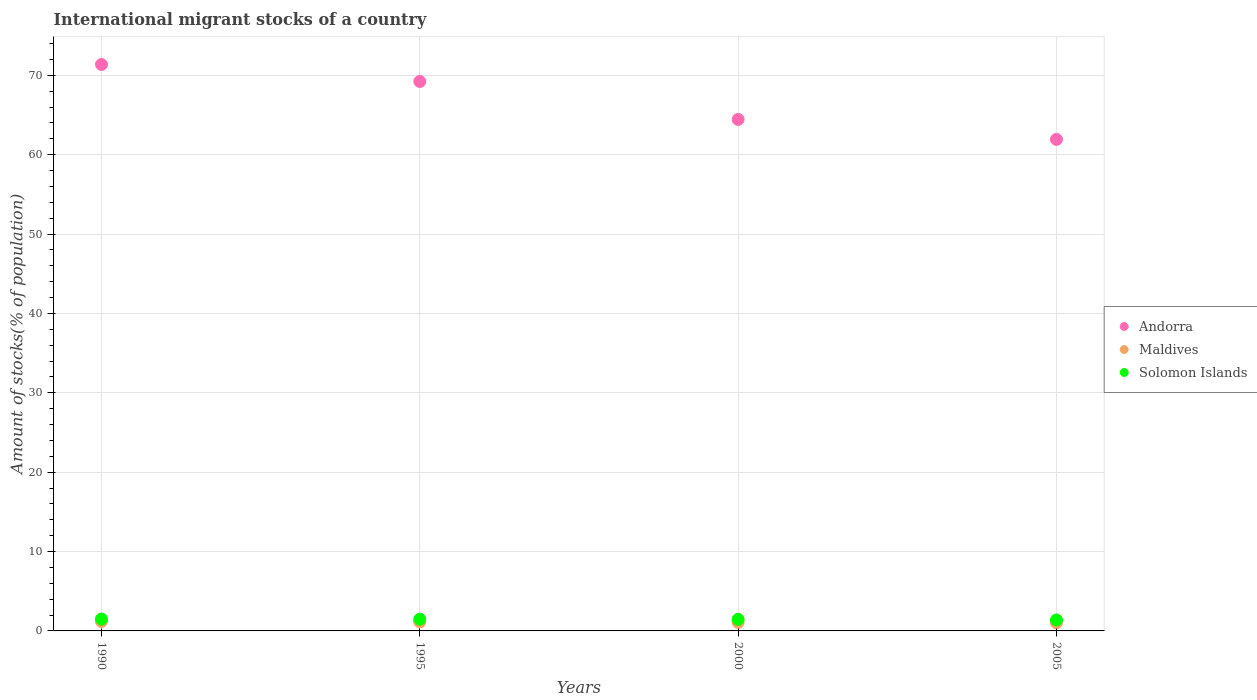Is the number of dotlines equal to the number of legend labels?
Keep it short and to the point. Yes. What is the amount of stocks in in Andorra in 1995?
Make the answer very short. 69.23. Across all years, what is the maximum amount of stocks in in Maldives?
Your answer should be very brief. 1.19. Across all years, what is the minimum amount of stocks in in Maldives?
Provide a succinct answer. 1.03. In which year was the amount of stocks in in Andorra maximum?
Keep it short and to the point. 1990. In which year was the amount of stocks in in Maldives minimum?
Your answer should be very brief. 2005. What is the total amount of stocks in in Andorra in the graph?
Your answer should be compact. 266.97. What is the difference between the amount of stocks in in Solomon Islands in 1995 and that in 2005?
Make the answer very short. 0.1. What is the difference between the amount of stocks in in Andorra in 1990 and the amount of stocks in in Maldives in 2000?
Offer a terse response. 70.29. What is the average amount of stocks in in Solomon Islands per year?
Your response must be concise. 1.45. In the year 1995, what is the difference between the amount of stocks in in Andorra and amount of stocks in in Maldives?
Give a very brief answer. 68.1. In how many years, is the amount of stocks in in Solomon Islands greater than 64 %?
Keep it short and to the point. 0. What is the ratio of the amount of stocks in in Andorra in 1990 to that in 1995?
Provide a succinct answer. 1.03. Is the amount of stocks in in Solomon Islands in 1995 less than that in 2005?
Keep it short and to the point. No. What is the difference between the highest and the second highest amount of stocks in in Maldives?
Your answer should be very brief. 0.06. What is the difference between the highest and the lowest amount of stocks in in Solomon Islands?
Make the answer very short. 0.12. In how many years, is the amount of stocks in in Solomon Islands greater than the average amount of stocks in in Solomon Islands taken over all years?
Your response must be concise. 3. Is the sum of the amount of stocks in in Maldives in 1990 and 1995 greater than the maximum amount of stocks in in Andorra across all years?
Give a very brief answer. No. Is it the case that in every year, the sum of the amount of stocks in in Andorra and amount of stocks in in Solomon Islands  is greater than the amount of stocks in in Maldives?
Provide a succinct answer. Yes. Is the amount of stocks in in Solomon Islands strictly greater than the amount of stocks in in Maldives over the years?
Offer a very short reply. Yes. How many dotlines are there?
Your response must be concise. 3. How many years are there in the graph?
Your answer should be compact. 4. Does the graph contain grids?
Make the answer very short. Yes. How many legend labels are there?
Your answer should be compact. 3. How are the legend labels stacked?
Your response must be concise. Vertical. What is the title of the graph?
Your response must be concise. International migrant stocks of a country. Does "Aruba" appear as one of the legend labels in the graph?
Offer a terse response. No. What is the label or title of the Y-axis?
Your response must be concise. Amount of stocks(% of population). What is the Amount of stocks(% of population) of Andorra in 1990?
Make the answer very short. 71.37. What is the Amount of stocks(% of population) of Maldives in 1990?
Ensure brevity in your answer.  1.19. What is the Amount of stocks(% of population) in Solomon Islands in 1990?
Ensure brevity in your answer.  1.5. What is the Amount of stocks(% of population) of Andorra in 1995?
Offer a terse response. 69.23. What is the Amount of stocks(% of population) of Maldives in 1995?
Give a very brief answer. 1.13. What is the Amount of stocks(% of population) in Solomon Islands in 1995?
Your answer should be very brief. 1.47. What is the Amount of stocks(% of population) of Andorra in 2000?
Your answer should be very brief. 64.44. What is the Amount of stocks(% of population) of Maldives in 2000?
Make the answer very short. 1.08. What is the Amount of stocks(% of population) of Solomon Islands in 2000?
Your response must be concise. 1.46. What is the Amount of stocks(% of population) in Andorra in 2005?
Give a very brief answer. 61.93. What is the Amount of stocks(% of population) of Maldives in 2005?
Offer a terse response. 1.03. What is the Amount of stocks(% of population) of Solomon Islands in 2005?
Your response must be concise. 1.38. Across all years, what is the maximum Amount of stocks(% of population) of Andorra?
Your response must be concise. 71.37. Across all years, what is the maximum Amount of stocks(% of population) of Maldives?
Offer a very short reply. 1.19. Across all years, what is the maximum Amount of stocks(% of population) in Solomon Islands?
Your answer should be compact. 1.5. Across all years, what is the minimum Amount of stocks(% of population) of Andorra?
Your response must be concise. 61.93. Across all years, what is the minimum Amount of stocks(% of population) of Maldives?
Give a very brief answer. 1.03. Across all years, what is the minimum Amount of stocks(% of population) of Solomon Islands?
Ensure brevity in your answer.  1.38. What is the total Amount of stocks(% of population) of Andorra in the graph?
Offer a very short reply. 266.97. What is the total Amount of stocks(% of population) in Maldives in the graph?
Provide a short and direct response. 4.43. What is the total Amount of stocks(% of population) of Solomon Islands in the graph?
Offer a terse response. 5.8. What is the difference between the Amount of stocks(% of population) of Andorra in 1990 and that in 1995?
Make the answer very short. 2.14. What is the difference between the Amount of stocks(% of population) of Maldives in 1990 and that in 1995?
Your answer should be very brief. 0.06. What is the difference between the Amount of stocks(% of population) in Solomon Islands in 1990 and that in 1995?
Make the answer very short. 0.02. What is the difference between the Amount of stocks(% of population) in Andorra in 1990 and that in 2000?
Give a very brief answer. 6.92. What is the difference between the Amount of stocks(% of population) in Maldives in 1990 and that in 2000?
Give a very brief answer. 0.11. What is the difference between the Amount of stocks(% of population) of Solomon Islands in 1990 and that in 2000?
Make the answer very short. 0.04. What is the difference between the Amount of stocks(% of population) of Andorra in 1990 and that in 2005?
Offer a very short reply. 9.44. What is the difference between the Amount of stocks(% of population) in Maldives in 1990 and that in 2005?
Ensure brevity in your answer.  0.16. What is the difference between the Amount of stocks(% of population) in Solomon Islands in 1990 and that in 2005?
Keep it short and to the point. 0.12. What is the difference between the Amount of stocks(% of population) in Andorra in 1995 and that in 2000?
Offer a very short reply. 4.78. What is the difference between the Amount of stocks(% of population) of Maldives in 1995 and that in 2000?
Offer a terse response. 0.05. What is the difference between the Amount of stocks(% of population) of Solomon Islands in 1995 and that in 2000?
Provide a short and direct response. 0.02. What is the difference between the Amount of stocks(% of population) of Andorra in 1995 and that in 2005?
Your response must be concise. 7.3. What is the difference between the Amount of stocks(% of population) of Maldives in 1995 and that in 2005?
Provide a succinct answer. 0.1. What is the difference between the Amount of stocks(% of population) of Solomon Islands in 1995 and that in 2005?
Provide a succinct answer. 0.1. What is the difference between the Amount of stocks(% of population) in Andorra in 2000 and that in 2005?
Provide a succinct answer. 2.51. What is the difference between the Amount of stocks(% of population) in Maldives in 2000 and that in 2005?
Offer a terse response. 0.05. What is the difference between the Amount of stocks(% of population) in Solomon Islands in 2000 and that in 2005?
Provide a succinct answer. 0.08. What is the difference between the Amount of stocks(% of population) in Andorra in 1990 and the Amount of stocks(% of population) in Maldives in 1995?
Give a very brief answer. 70.24. What is the difference between the Amount of stocks(% of population) in Andorra in 1990 and the Amount of stocks(% of population) in Solomon Islands in 1995?
Your answer should be compact. 69.9. What is the difference between the Amount of stocks(% of population) in Maldives in 1990 and the Amount of stocks(% of population) in Solomon Islands in 1995?
Make the answer very short. -0.29. What is the difference between the Amount of stocks(% of population) of Andorra in 1990 and the Amount of stocks(% of population) of Maldives in 2000?
Offer a terse response. 70.29. What is the difference between the Amount of stocks(% of population) of Andorra in 1990 and the Amount of stocks(% of population) of Solomon Islands in 2000?
Offer a very short reply. 69.91. What is the difference between the Amount of stocks(% of population) in Maldives in 1990 and the Amount of stocks(% of population) in Solomon Islands in 2000?
Make the answer very short. -0.27. What is the difference between the Amount of stocks(% of population) in Andorra in 1990 and the Amount of stocks(% of population) in Maldives in 2005?
Your answer should be very brief. 70.34. What is the difference between the Amount of stocks(% of population) of Andorra in 1990 and the Amount of stocks(% of population) of Solomon Islands in 2005?
Make the answer very short. 69.99. What is the difference between the Amount of stocks(% of population) in Maldives in 1990 and the Amount of stocks(% of population) in Solomon Islands in 2005?
Make the answer very short. -0.19. What is the difference between the Amount of stocks(% of population) of Andorra in 1995 and the Amount of stocks(% of population) of Maldives in 2000?
Make the answer very short. 68.15. What is the difference between the Amount of stocks(% of population) in Andorra in 1995 and the Amount of stocks(% of population) in Solomon Islands in 2000?
Your answer should be very brief. 67.77. What is the difference between the Amount of stocks(% of population) in Maldives in 1995 and the Amount of stocks(% of population) in Solomon Islands in 2000?
Ensure brevity in your answer.  -0.33. What is the difference between the Amount of stocks(% of population) of Andorra in 1995 and the Amount of stocks(% of population) of Maldives in 2005?
Ensure brevity in your answer.  68.19. What is the difference between the Amount of stocks(% of population) of Andorra in 1995 and the Amount of stocks(% of population) of Solomon Islands in 2005?
Your answer should be compact. 67.85. What is the difference between the Amount of stocks(% of population) in Maldives in 1995 and the Amount of stocks(% of population) in Solomon Islands in 2005?
Provide a short and direct response. -0.25. What is the difference between the Amount of stocks(% of population) of Andorra in 2000 and the Amount of stocks(% of population) of Maldives in 2005?
Offer a terse response. 63.41. What is the difference between the Amount of stocks(% of population) of Andorra in 2000 and the Amount of stocks(% of population) of Solomon Islands in 2005?
Your answer should be compact. 63.07. What is the difference between the Amount of stocks(% of population) of Maldives in 2000 and the Amount of stocks(% of population) of Solomon Islands in 2005?
Your answer should be compact. -0.3. What is the average Amount of stocks(% of population) of Andorra per year?
Your response must be concise. 66.74. What is the average Amount of stocks(% of population) of Maldives per year?
Offer a terse response. 1.11. What is the average Amount of stocks(% of population) in Solomon Islands per year?
Provide a succinct answer. 1.45. In the year 1990, what is the difference between the Amount of stocks(% of population) in Andorra and Amount of stocks(% of population) in Maldives?
Make the answer very short. 70.18. In the year 1990, what is the difference between the Amount of stocks(% of population) of Andorra and Amount of stocks(% of population) of Solomon Islands?
Give a very brief answer. 69.87. In the year 1990, what is the difference between the Amount of stocks(% of population) in Maldives and Amount of stocks(% of population) in Solomon Islands?
Ensure brevity in your answer.  -0.31. In the year 1995, what is the difference between the Amount of stocks(% of population) in Andorra and Amount of stocks(% of population) in Maldives?
Offer a terse response. 68.1. In the year 1995, what is the difference between the Amount of stocks(% of population) in Andorra and Amount of stocks(% of population) in Solomon Islands?
Your answer should be very brief. 67.75. In the year 1995, what is the difference between the Amount of stocks(% of population) in Maldives and Amount of stocks(% of population) in Solomon Islands?
Offer a terse response. -0.34. In the year 2000, what is the difference between the Amount of stocks(% of population) of Andorra and Amount of stocks(% of population) of Maldives?
Provide a succinct answer. 63.37. In the year 2000, what is the difference between the Amount of stocks(% of population) in Andorra and Amount of stocks(% of population) in Solomon Islands?
Your answer should be very brief. 62.99. In the year 2000, what is the difference between the Amount of stocks(% of population) of Maldives and Amount of stocks(% of population) of Solomon Islands?
Offer a very short reply. -0.38. In the year 2005, what is the difference between the Amount of stocks(% of population) of Andorra and Amount of stocks(% of population) of Maldives?
Your answer should be very brief. 60.9. In the year 2005, what is the difference between the Amount of stocks(% of population) in Andorra and Amount of stocks(% of population) in Solomon Islands?
Ensure brevity in your answer.  60.55. In the year 2005, what is the difference between the Amount of stocks(% of population) in Maldives and Amount of stocks(% of population) in Solomon Islands?
Ensure brevity in your answer.  -0.34. What is the ratio of the Amount of stocks(% of population) in Andorra in 1990 to that in 1995?
Make the answer very short. 1.03. What is the ratio of the Amount of stocks(% of population) in Maldives in 1990 to that in 1995?
Provide a succinct answer. 1.05. What is the ratio of the Amount of stocks(% of population) of Solomon Islands in 1990 to that in 1995?
Provide a succinct answer. 1.02. What is the ratio of the Amount of stocks(% of population) in Andorra in 1990 to that in 2000?
Provide a succinct answer. 1.11. What is the ratio of the Amount of stocks(% of population) in Maldives in 1990 to that in 2000?
Ensure brevity in your answer.  1.1. What is the ratio of the Amount of stocks(% of population) of Solomon Islands in 1990 to that in 2000?
Offer a terse response. 1.03. What is the ratio of the Amount of stocks(% of population) in Andorra in 1990 to that in 2005?
Provide a short and direct response. 1.15. What is the ratio of the Amount of stocks(% of population) in Maldives in 1990 to that in 2005?
Offer a very short reply. 1.15. What is the ratio of the Amount of stocks(% of population) in Solomon Islands in 1990 to that in 2005?
Your answer should be compact. 1.09. What is the ratio of the Amount of stocks(% of population) of Andorra in 1995 to that in 2000?
Provide a short and direct response. 1.07. What is the ratio of the Amount of stocks(% of population) of Maldives in 1995 to that in 2000?
Keep it short and to the point. 1.05. What is the ratio of the Amount of stocks(% of population) of Solomon Islands in 1995 to that in 2000?
Make the answer very short. 1.01. What is the ratio of the Amount of stocks(% of population) in Andorra in 1995 to that in 2005?
Offer a very short reply. 1.12. What is the ratio of the Amount of stocks(% of population) of Maldives in 1995 to that in 2005?
Give a very brief answer. 1.09. What is the ratio of the Amount of stocks(% of population) of Solomon Islands in 1995 to that in 2005?
Make the answer very short. 1.07. What is the ratio of the Amount of stocks(% of population) in Andorra in 2000 to that in 2005?
Keep it short and to the point. 1.04. What is the ratio of the Amount of stocks(% of population) in Maldives in 2000 to that in 2005?
Make the answer very short. 1.04. What is the ratio of the Amount of stocks(% of population) in Solomon Islands in 2000 to that in 2005?
Make the answer very short. 1.06. What is the difference between the highest and the second highest Amount of stocks(% of population) in Andorra?
Your answer should be compact. 2.14. What is the difference between the highest and the second highest Amount of stocks(% of population) in Maldives?
Ensure brevity in your answer.  0.06. What is the difference between the highest and the second highest Amount of stocks(% of population) of Solomon Islands?
Provide a short and direct response. 0.02. What is the difference between the highest and the lowest Amount of stocks(% of population) of Andorra?
Your answer should be very brief. 9.44. What is the difference between the highest and the lowest Amount of stocks(% of population) of Maldives?
Keep it short and to the point. 0.16. What is the difference between the highest and the lowest Amount of stocks(% of population) in Solomon Islands?
Your answer should be very brief. 0.12. 